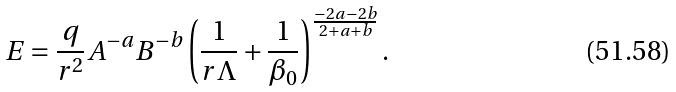<formula> <loc_0><loc_0><loc_500><loc_500>E = \frac { q } { r ^ { 2 } } A ^ { - a } B ^ { - b } \left ( \frac { 1 } { r \Lambda } + \frac { 1 } { \beta _ { 0 } } \right ) ^ { \frac { - 2 a - 2 b } { 2 + a + b } } .</formula> 